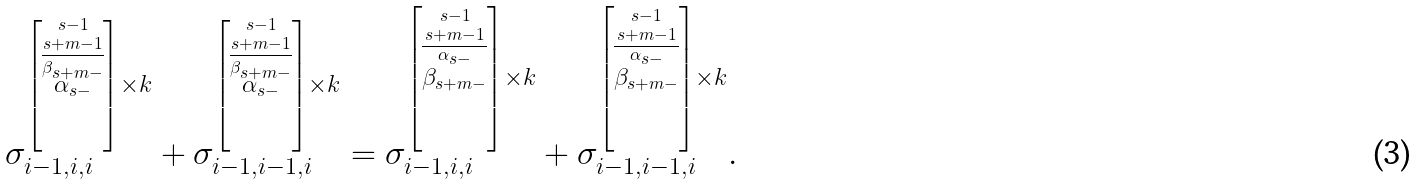<formula> <loc_0><loc_0><loc_500><loc_500>\sigma _ { i - 1 , i , i } ^ { \left [ \stackrel { s - 1 } { \stackrel { s + m - 1 } { \overline { \stackrel { \beta _ { s + m - } } { \alpha _ { s - } } } } } \right ] \times k } + \sigma _ { i - 1 , i - 1 , i } ^ { \left [ \stackrel { s - 1 } { \stackrel { s + m - 1 } { \overline { \stackrel { \beta _ { s + m - } } { \alpha _ { s - } } } } } \right ] \times k } = \sigma _ { i - 1 , i , i } ^ { \left [ \stackrel { s - 1 } { \stackrel { s + m - 1 } { \overline { \stackrel { \alpha _ { s - } } { \beta _ { s + m - } } } } } \right ] \times k } + \sigma _ { i - 1 , i - 1 , i } ^ { \left [ \stackrel { s - 1 } { \stackrel { s + m - 1 } { \overline { \stackrel { \alpha _ { s - } } { \beta _ { s + m - } } } } } \right ] \times k } .</formula> 